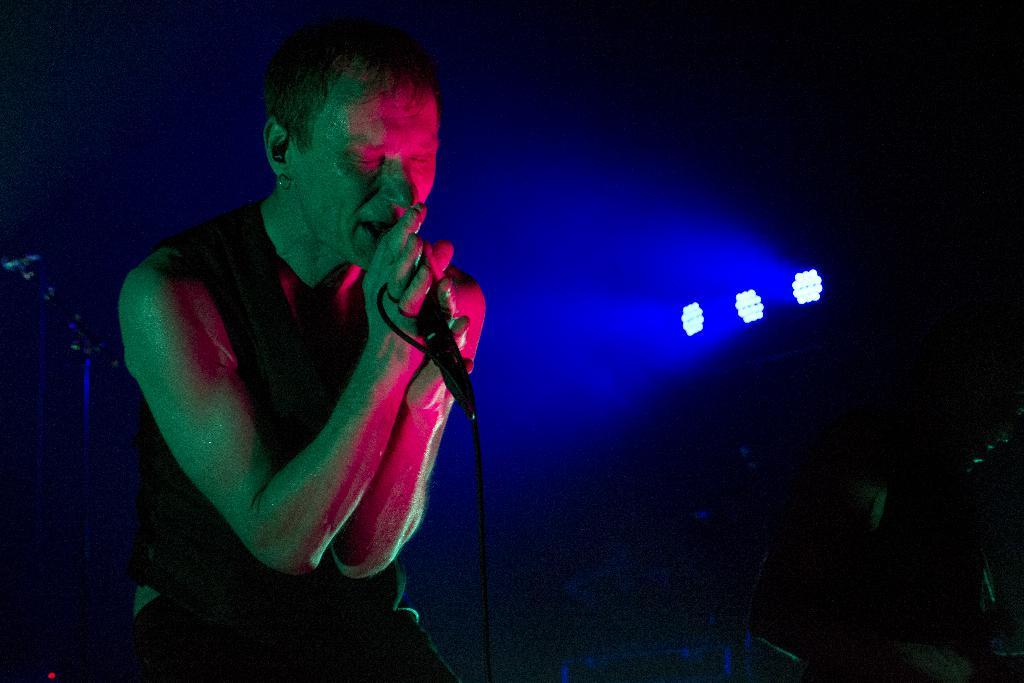Who is in the image? There is a person in the image. What is the person holding? The person is holding a mic. What can be seen in the background of the image? There is a stand and lights visible in the background of the image. How much money is being washed in the image? There is no mention of money or washing in the image; it features a person holding a mic with a stand and lights in the background. 